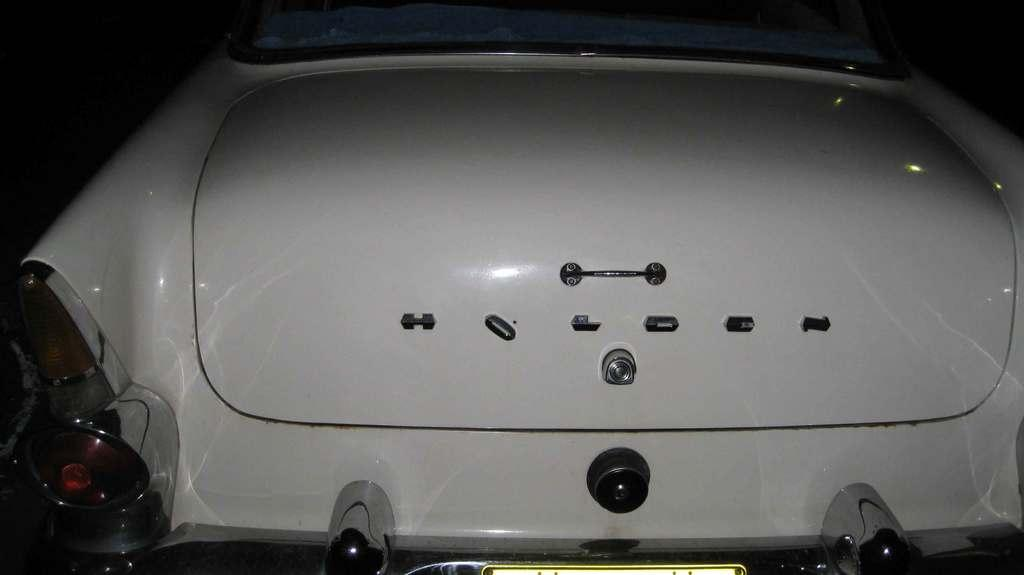What type of object is in the image? There is a vehicle in the image. What feature does the vehicle have? The vehicle has a handle attached to it. Is there any identification on the vehicle? Yes, there is a number plate attached to the bottom of the vehicle. What is unique about the number plate? The number plate has lights on it. What type of mint is being used to decorate the skirt in the image? There is no mint or skirt present in the image; it features a vehicle with a handle, a number plate, and lights on the number plate. 